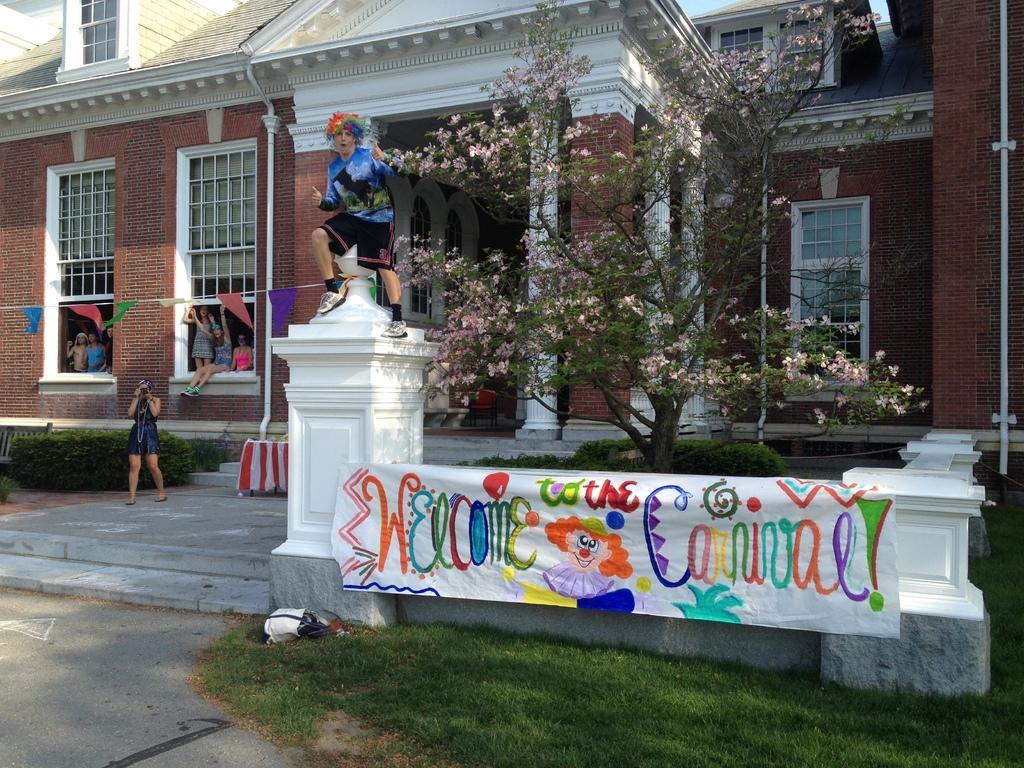In one or two sentences, can you explain what this image depicts? In this image we can see a building. In front of the building, tree is there and grassy land is present. We can see one boundary wall. On boundary wall, colorful cloth is there and one lady is standing on the pole of the wall. Left side of the image women are standing and sitting in window. And one lady is standing by holding camera in her hand. Behind the lady plants are there. 